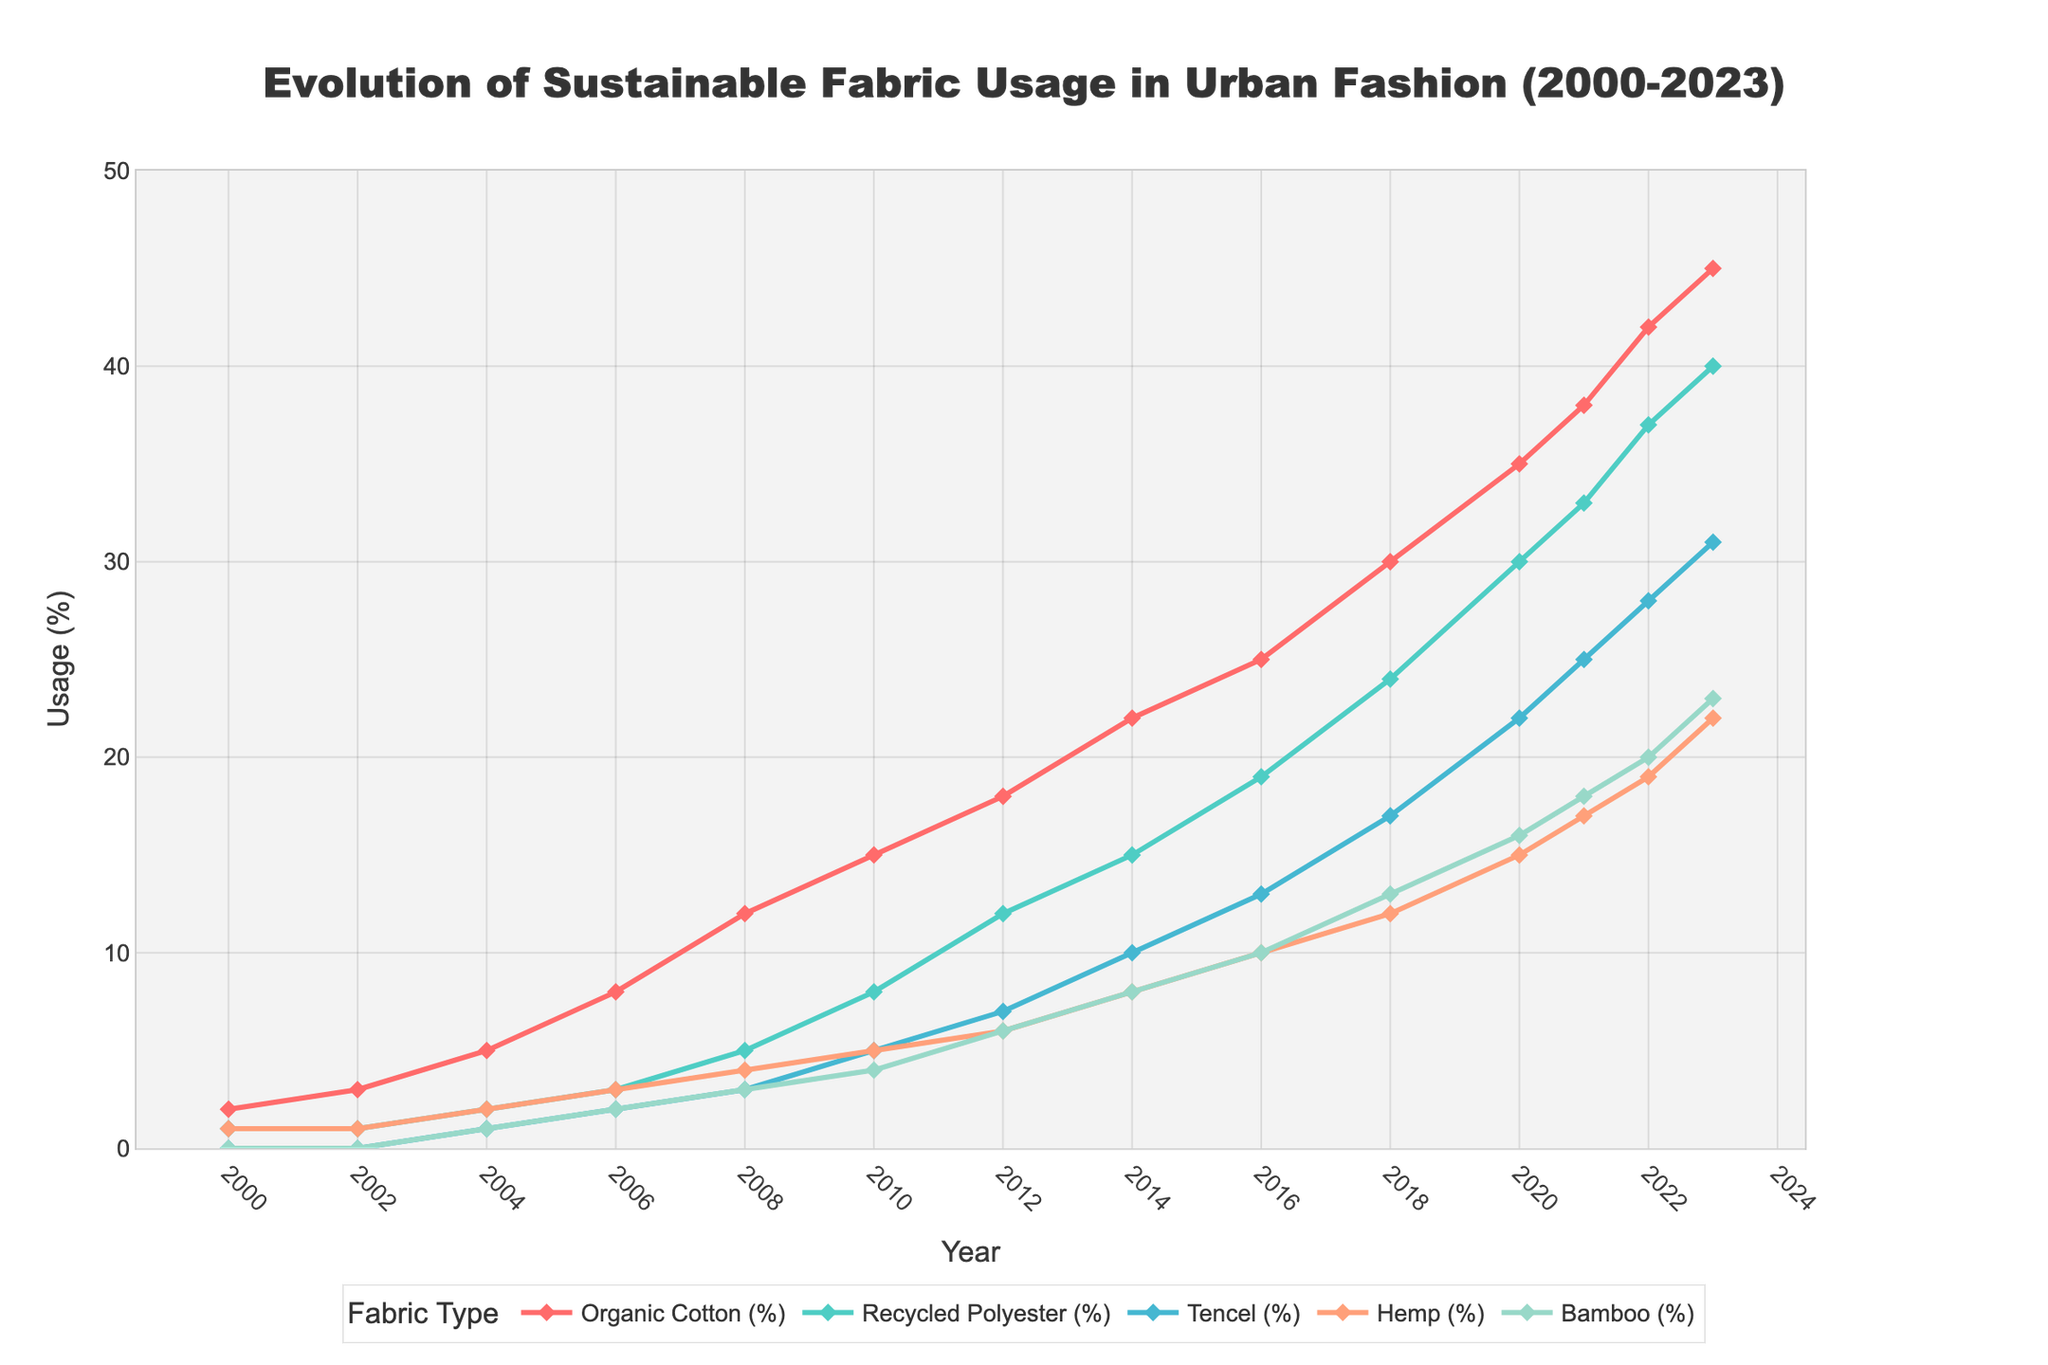What is the trend for organic cotton usage from 2000 to 2023? Organic cotton usage shows a steadily increasing trend from 2% in 2000 to 45% in 2023.
Answer: Increasing In which year did recycled polyester usage first surpass 10%? By examining the timeline of recycled polyester usage, it first surpasses 10% in 2012.
Answer: 2012 Which fabric had the highest usage percentage in 2023? In 2023, organic cotton had the highest usage percentage at 45%, out of all the fabrics in the chart.
Answer: Organic cotton How did the usage of bamboo fabrics change between 2008 and 2023? Bamboo usage increased from 3% in 2008 to 23% in 2023. The trend shows consistent growth over this period.
Answer: Increased Comparing 2010 and 2020, which fabric saw the highest increase in usage percentage? Comparing usage in 2010 and 2020:
- Organic Cotton: 20% increase (15% to 35%)
- Recycled Polyester: 22% increase (8% to 30%)
- Tencel: 17% increase (5% to 22%)
- Hemp: 10% increase (5% to 15%)
- Bamboo: 12% increase (4% to 16%)
Recycled Polyester shows the highest increase of 22%.
Answer: Recycled Polyester What is the average annual increase in organic cotton usage between 2000 and 2023? Calculate total increase: 45% - 2% = 43%. Number of years: 2023 - 2000 = 23. Average annual increase = 43% / 23 ≈ 1.87% per year.
Answer: 1.87% Which fabric usage grew at a constant rate throughout the period? By observing the slope and the increments over time from the data, Tencel shows relatively steady and constant increments.
Answer: Tencel In what year did both organic cotton and recycled polyester reach almost the same usage percentage? Looking at the data, in 2016, the usage of organic cotton was at 25% and recycled polyester was at 19%. The closest values without exactly matching.
Answer: 2016 What color represents hemp fabric in the plotted chart? The color coding identifies hemp fabric represented by the orange color in the plotted chart.
Answer: Orange How many years did it take for bamboo usage to reach 20% from 0%? Bamboo starts at 0% in 2000 and reaches 20% in 2022. From the year 2000 to 2022, it takes 22 years.
Answer: 22 years 